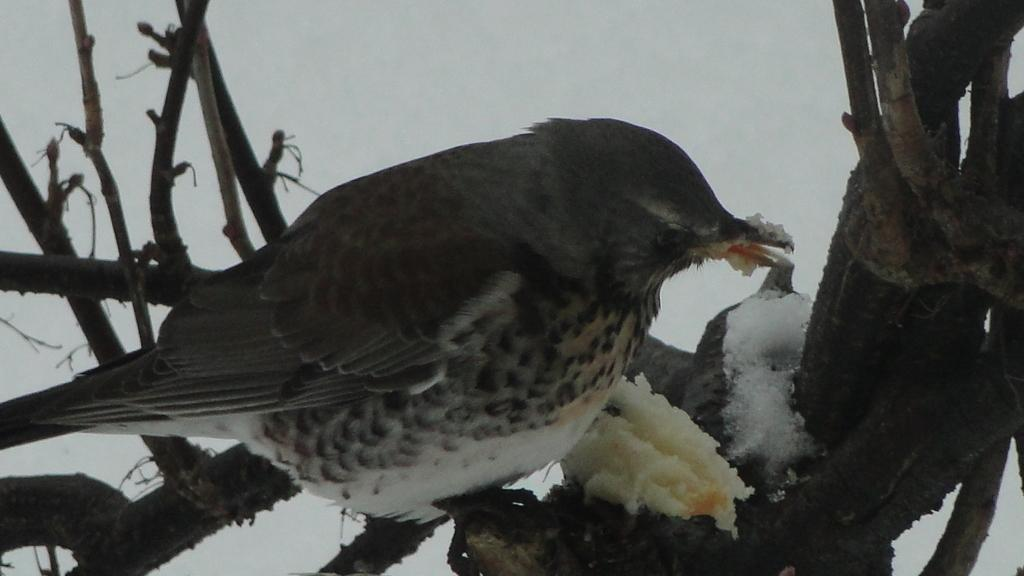What is the main subject in the foreground of the image? There is a bird in the foreground of the image. Where is the bird located? The bird is on a nest. What is the bird doing in the image? The bird is eating food. What can be observed about the background of the image? The background of the image appears to be snowy. Can you see the bird's foot touching the canvas in the image? There is no canvas present in the image, and the bird's foot cannot be seen touching anything, as it is on a nest. 